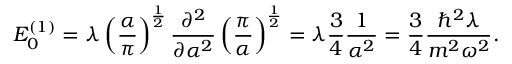Convert formula to latex. <formula><loc_0><loc_0><loc_500><loc_500>E _ { 0 } ^ { ( 1 ) } = \lambda \left ( { \frac { \alpha } { \pi } } \right ) ^ { \frac { 1 } { 2 } } { \frac { \partial ^ { 2 } } { \partial \alpha ^ { 2 } } } \left ( { \frac { \pi } { \alpha } } \right ) ^ { \frac { 1 } { 2 } } = \lambda { \frac { 3 } { 4 } } { \frac { 1 } { \alpha ^ { 2 } } } = { \frac { 3 } { 4 } } { \frac { \hbar { ^ } { 2 } \lambda } { m ^ { 2 } \omega ^ { 2 } } } .</formula> 